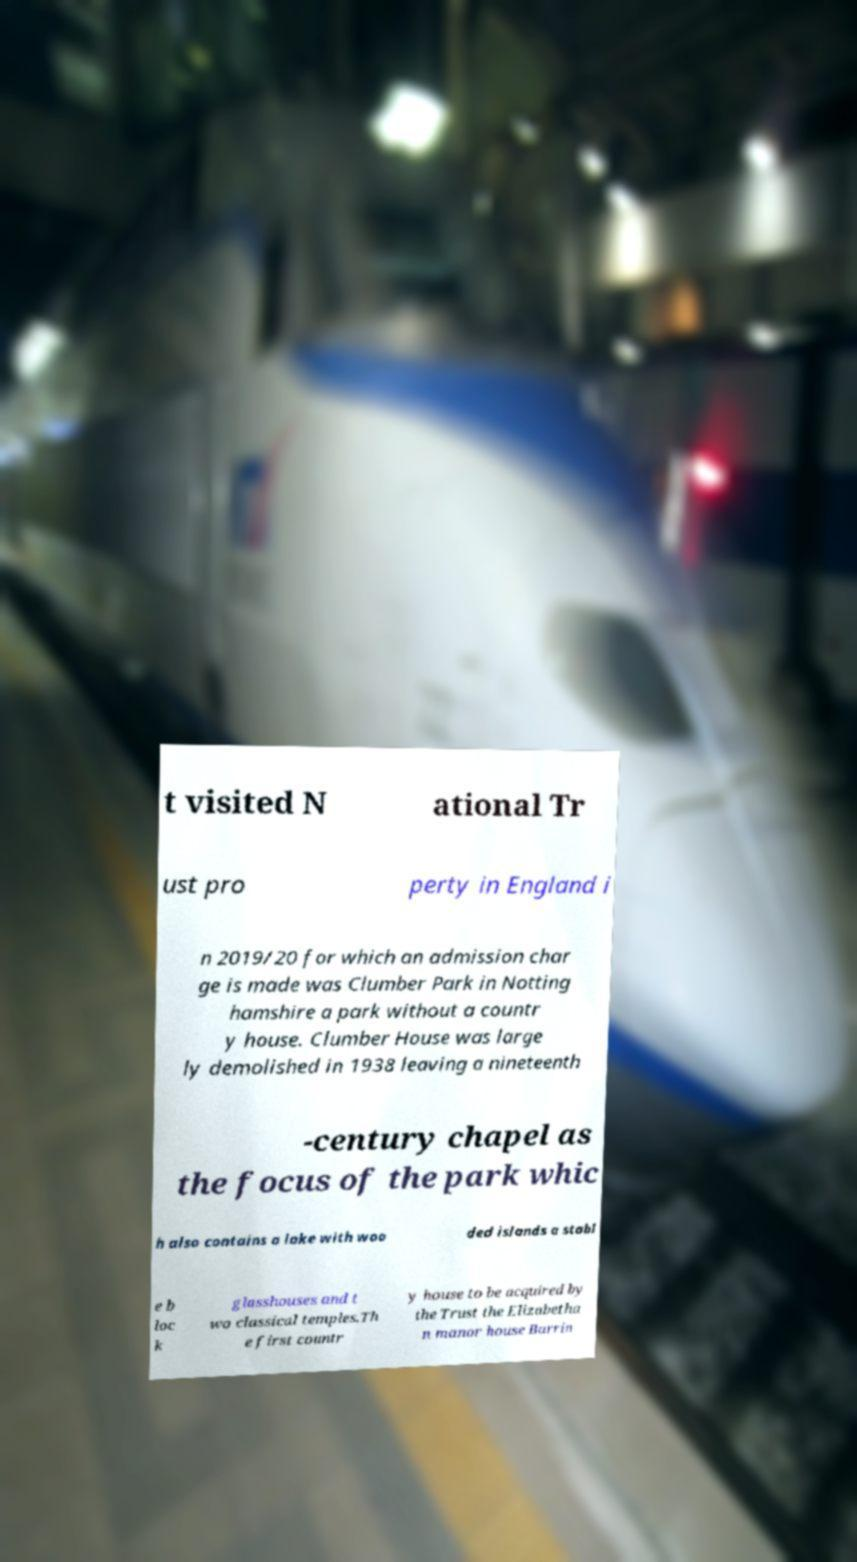I need the written content from this picture converted into text. Can you do that? t visited N ational Tr ust pro perty in England i n 2019/20 for which an admission char ge is made was Clumber Park in Notting hamshire a park without a countr y house. Clumber House was large ly demolished in 1938 leaving a nineteenth -century chapel as the focus of the park whic h also contains a lake with woo ded islands a stabl e b loc k glasshouses and t wo classical temples.Th e first countr y house to be acquired by the Trust the Elizabetha n manor house Barrin 